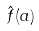Convert formula to latex. <formula><loc_0><loc_0><loc_500><loc_500>\hat { f } ( a )</formula> 